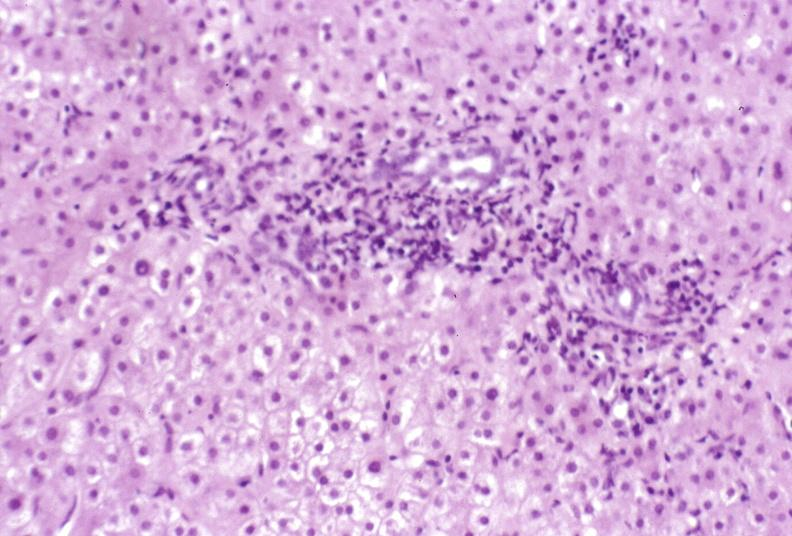what is present?
Answer the question using a single word or phrase. Liver 